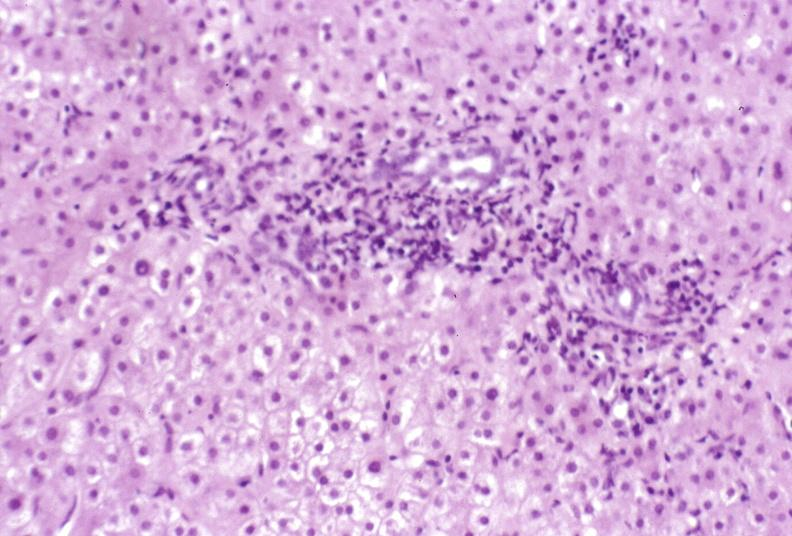what is present?
Answer the question using a single word or phrase. Liver 